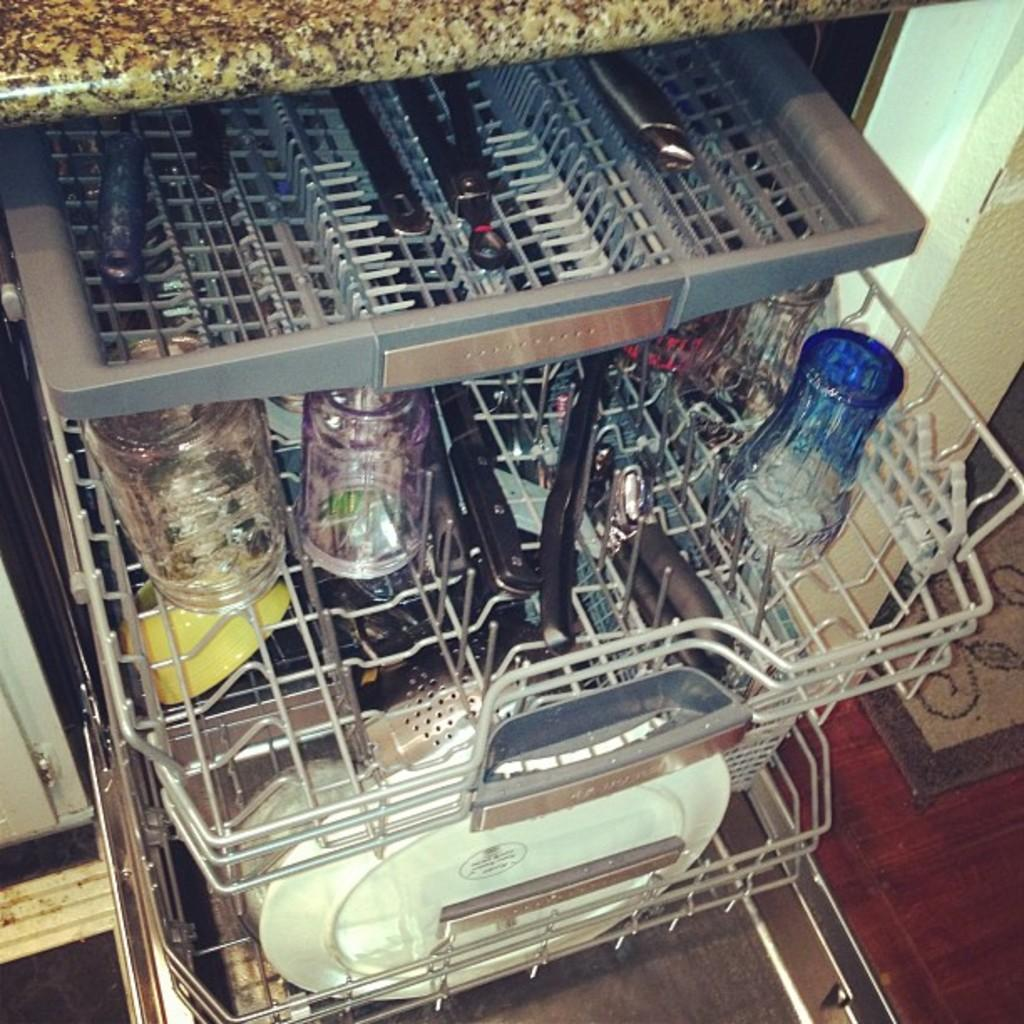What is the main object in the center of the image? There is a trolley in the center of the image. What is on the trolley? The trolley contains bottles and plates. What type of surface is visible beneath the trolley? There is a floor visible in the image. Is there any additional decoration or item on the floor? Yes, there is a doormat on the floor. What type of yam is growing on the doormat in the image? There is no yam present in the image, and therefore no such growth can be observed on the doormat. 